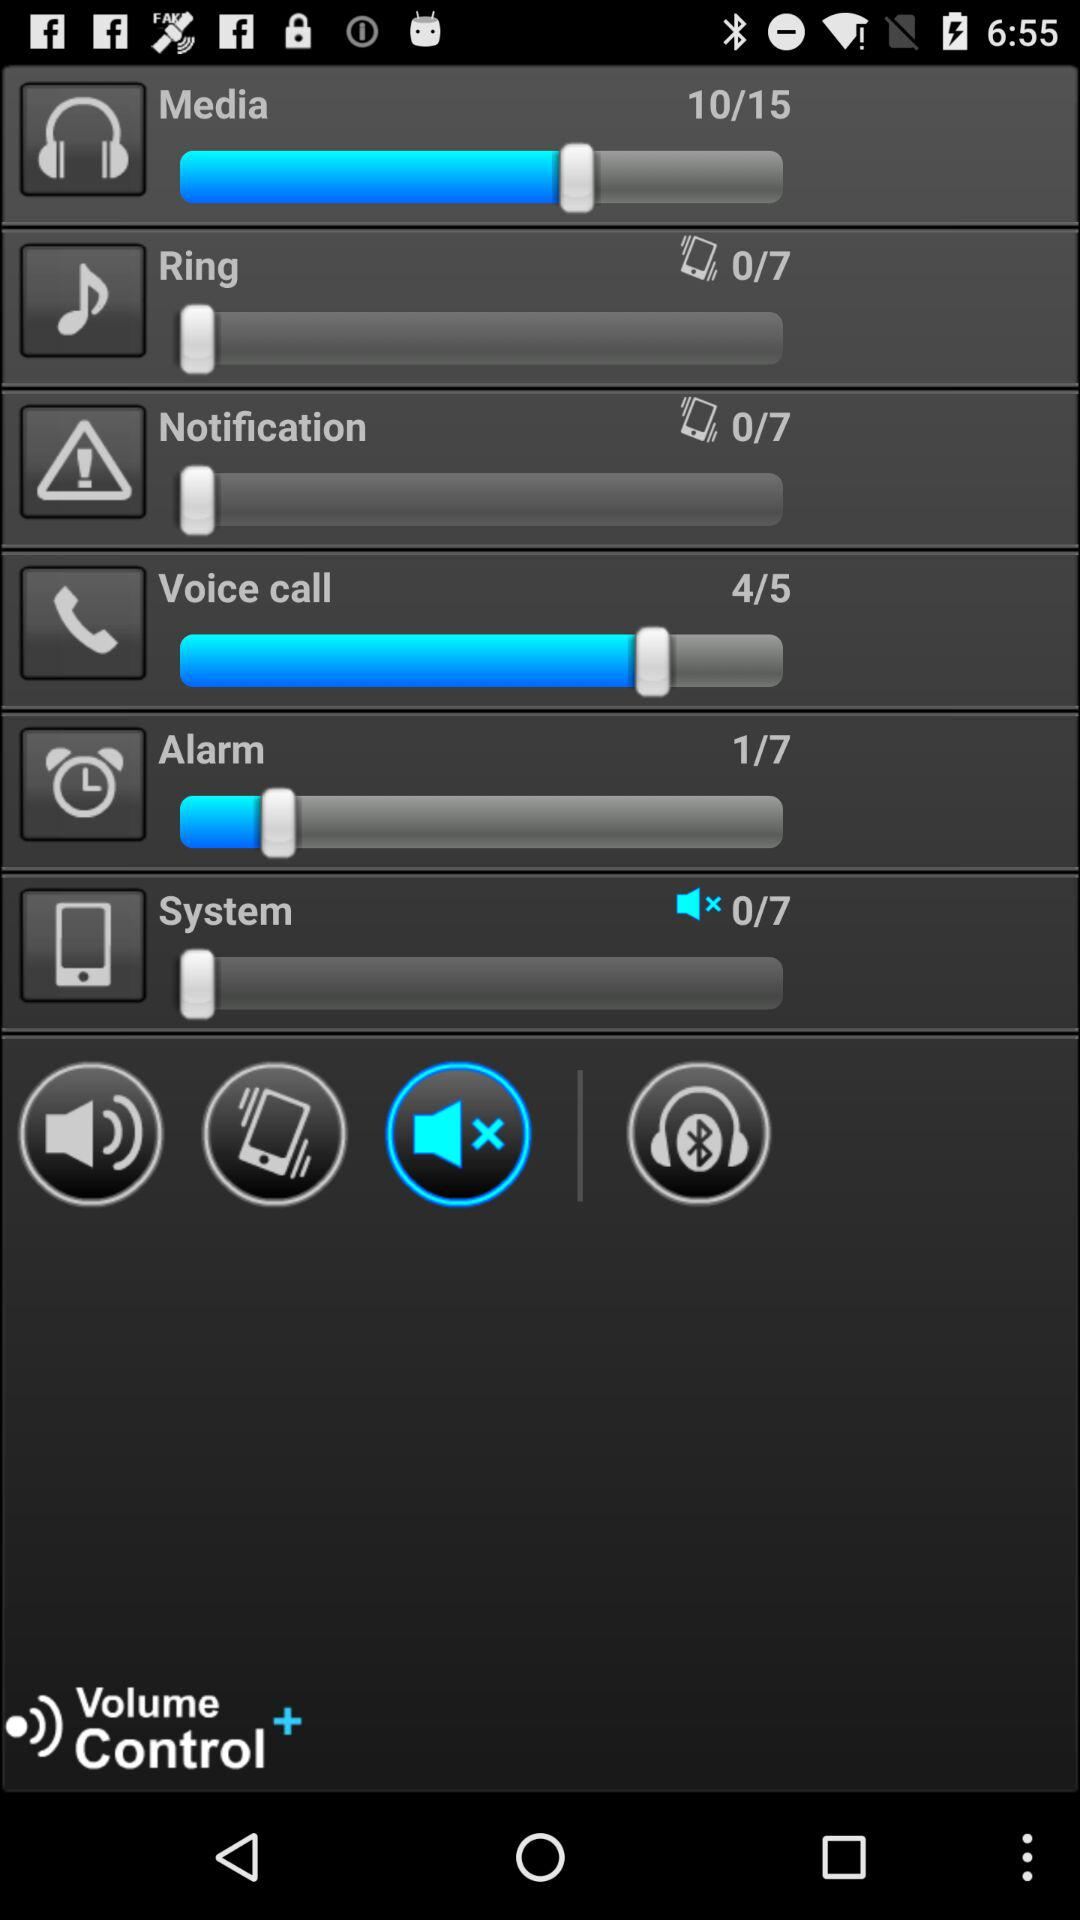What is the total number of media?
When the provided information is insufficient, respond with <no answer>. <no answer> 